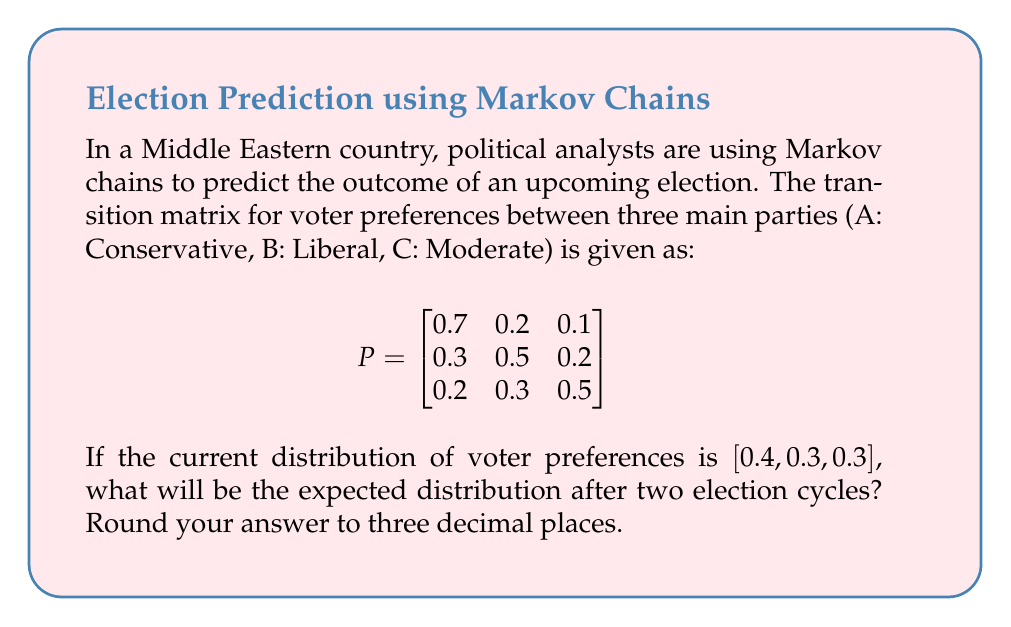What is the answer to this math problem? To solve this problem, we need to use the Markov chain transition matrix and multiply it by the initial state vector twice. Let's break it down step-by-step:

1. Initial state vector: $v_0 = [0.4, 0.3, 0.3]$

2. To find the distribution after one election cycle, we multiply $v_0$ by the transition matrix $P$:

   $v_1 = v_0 \cdot P$

   $v_1 = [0.4, 0.3, 0.3] \cdot \begin{bmatrix}
   0.7 & 0.2 & 0.1 \\
   0.3 & 0.5 & 0.2 \\
   0.2 & 0.3 & 0.5
   \end{bmatrix}$

   $v_1 = [0.4(0.7) + 0.3(0.3) + 0.3(0.2), 0.4(0.2) + 0.3(0.5) + 0.3(0.3), 0.4(0.1) + 0.3(0.2) + 0.3(0.5)]$

   $v_1 = [0.28 + 0.09 + 0.06, 0.08 + 0.15 + 0.09, 0.04 + 0.06 + 0.15]$

   $v_1 = [0.43, 0.32, 0.25]$

3. To find the distribution after two election cycles, we multiply $v_1$ by $P$ again:

   $v_2 = v_1 \cdot P$

   $v_2 = [0.43, 0.32, 0.25] \cdot \begin{bmatrix}
   0.7 & 0.2 & 0.1 \\
   0.3 & 0.5 & 0.2 \\
   0.2 & 0.3 & 0.5
   \end{bmatrix}$

   $v_2 = [0.43(0.7) + 0.32(0.3) + 0.25(0.2), 0.43(0.2) + 0.32(0.5) + 0.25(0.3), 0.43(0.1) + 0.32(0.2) + 0.25(0.5)]$

   $v_2 = [0.301 + 0.096 + 0.050, 0.086 + 0.160 + 0.075, 0.043 + 0.064 + 0.125]$

   $v_2 = [0.447, 0.321, 0.232]$

4. Rounding to three decimal places:

   $v_2 \approx [0.447, 0.321, 0.232]$

Therefore, the expected distribution of voter preferences after two election cycles is approximately [0.447, 0.321, 0.232].
Answer: [0.447, 0.321, 0.232] 